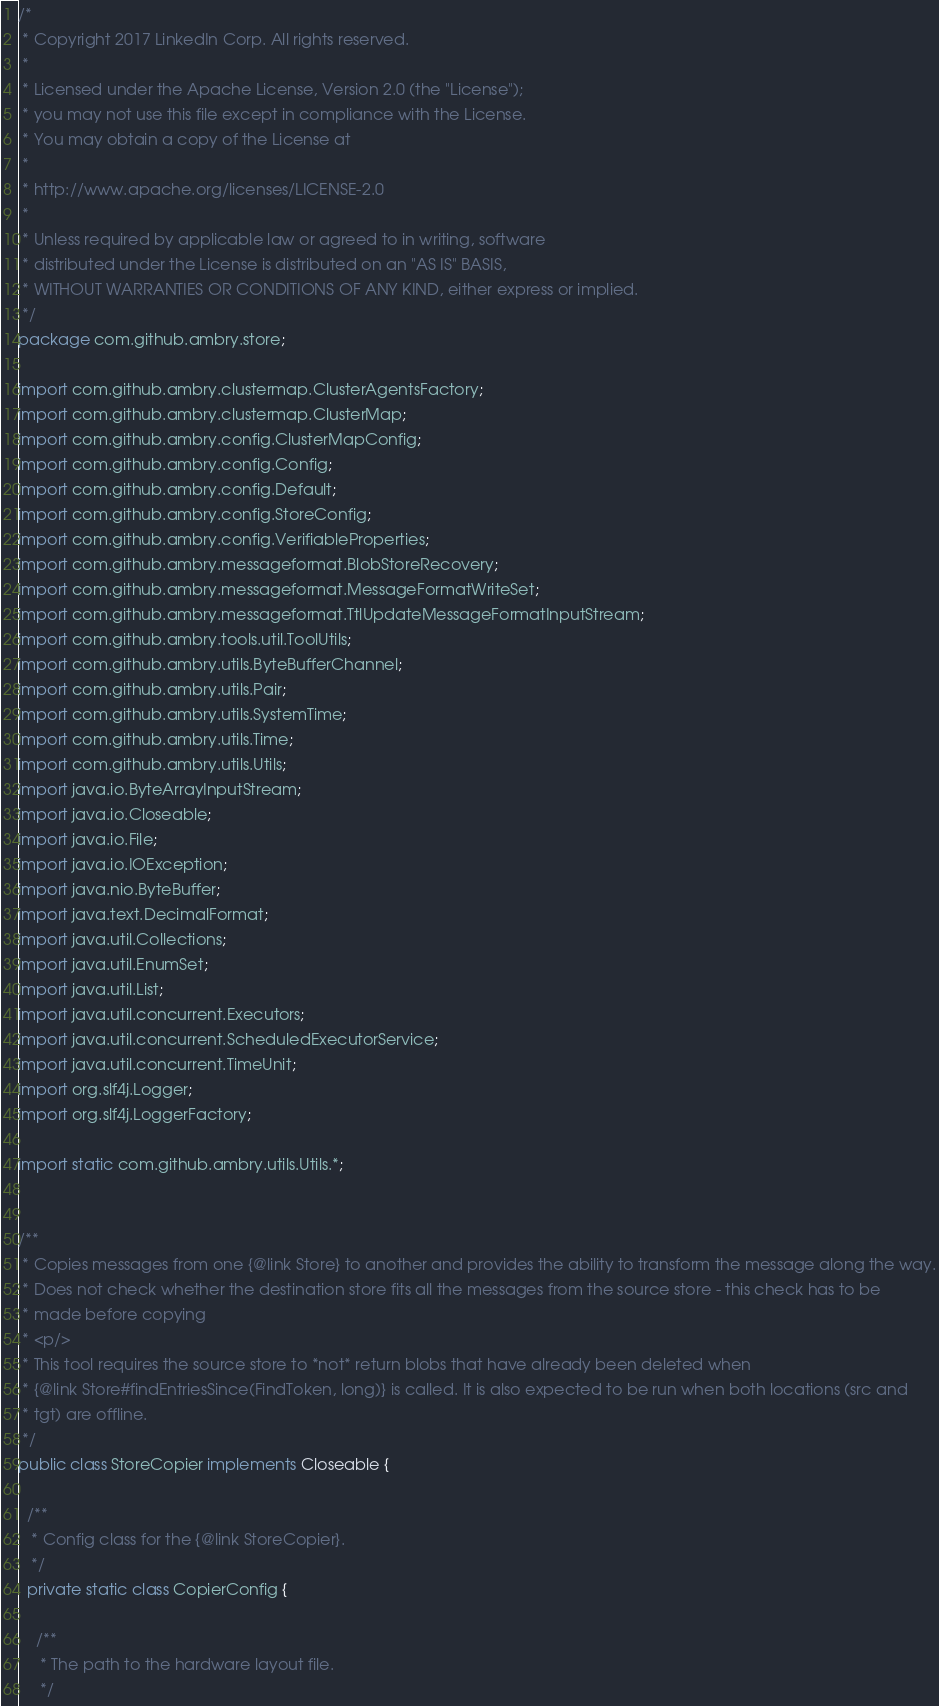<code> <loc_0><loc_0><loc_500><loc_500><_Java_>/*
 * Copyright 2017 LinkedIn Corp. All rights reserved.
 *
 * Licensed under the Apache License, Version 2.0 (the "License");
 * you may not use this file except in compliance with the License.
 * You may obtain a copy of the License at
 *
 * http://www.apache.org/licenses/LICENSE-2.0
 *
 * Unless required by applicable law or agreed to in writing, software
 * distributed under the License is distributed on an "AS IS" BASIS,
 * WITHOUT WARRANTIES OR CONDITIONS OF ANY KIND, either express or implied.
 */
package com.github.ambry.store;

import com.github.ambry.clustermap.ClusterAgentsFactory;
import com.github.ambry.clustermap.ClusterMap;
import com.github.ambry.config.ClusterMapConfig;
import com.github.ambry.config.Config;
import com.github.ambry.config.Default;
import com.github.ambry.config.StoreConfig;
import com.github.ambry.config.VerifiableProperties;
import com.github.ambry.messageformat.BlobStoreRecovery;
import com.github.ambry.messageformat.MessageFormatWriteSet;
import com.github.ambry.messageformat.TtlUpdateMessageFormatInputStream;
import com.github.ambry.tools.util.ToolUtils;
import com.github.ambry.utils.ByteBufferChannel;
import com.github.ambry.utils.Pair;
import com.github.ambry.utils.SystemTime;
import com.github.ambry.utils.Time;
import com.github.ambry.utils.Utils;
import java.io.ByteArrayInputStream;
import java.io.Closeable;
import java.io.File;
import java.io.IOException;
import java.nio.ByteBuffer;
import java.text.DecimalFormat;
import java.util.Collections;
import java.util.EnumSet;
import java.util.List;
import java.util.concurrent.Executors;
import java.util.concurrent.ScheduledExecutorService;
import java.util.concurrent.TimeUnit;
import org.slf4j.Logger;
import org.slf4j.LoggerFactory;

import static com.github.ambry.utils.Utils.*;


/**
 * Copies messages from one {@link Store} to another and provides the ability to transform the message along the way.
 * Does not check whether the destination store fits all the messages from the source store - this check has to be
 * made before copying
 * <p/>
 * This tool requires the source store to *not* return blobs that have already been deleted when
 * {@link Store#findEntriesSince(FindToken, long)} is called. It is also expected to be run when both locations (src and
 * tgt) are offline.
 */
public class StoreCopier implements Closeable {

  /**
   * Config class for the {@link StoreCopier}.
   */
  private static class CopierConfig {

    /**
     * The path to the hardware layout file.
     */</code> 